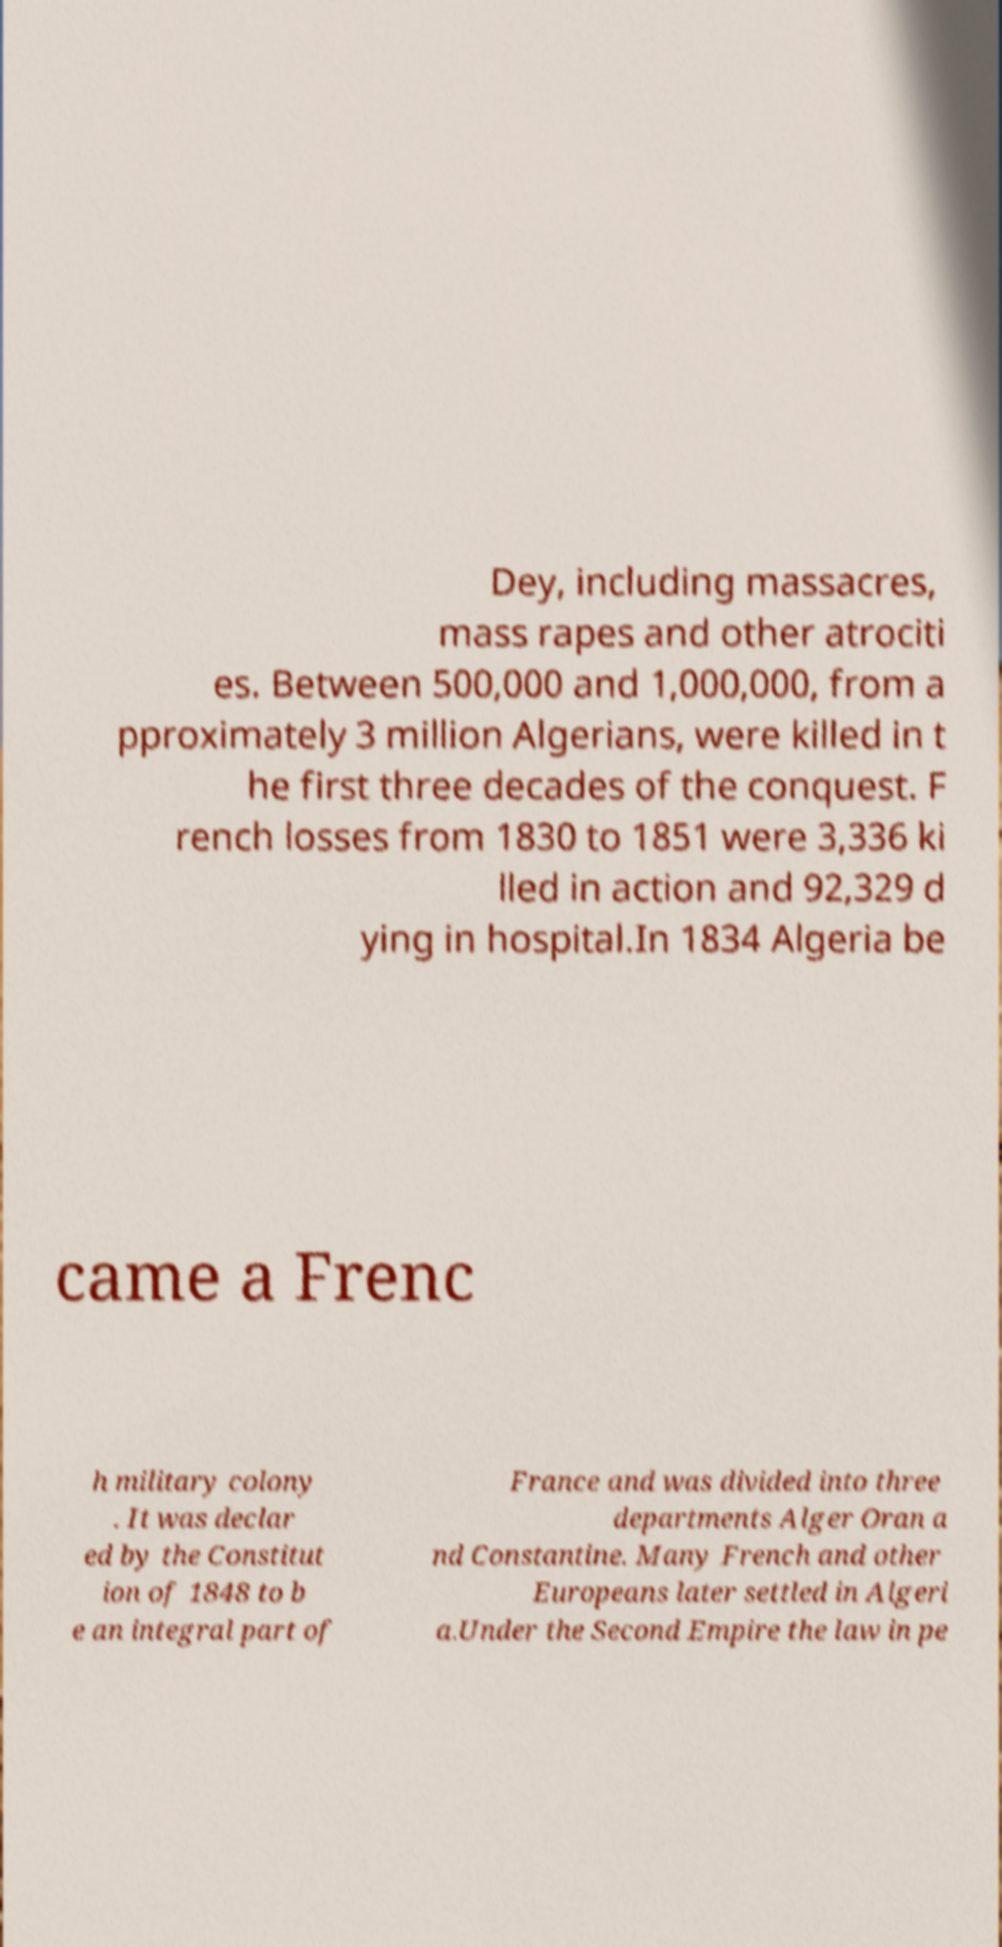Could you extract and type out the text from this image? Dey, including massacres, mass rapes and other atrociti es. Between 500,000 and 1,000,000, from a pproximately 3 million Algerians, were killed in t he first three decades of the conquest. F rench losses from 1830 to 1851 were 3,336 ki lled in action and 92,329 d ying in hospital.In 1834 Algeria be came a Frenc h military colony . It was declar ed by the Constitut ion of 1848 to b e an integral part of France and was divided into three departments Alger Oran a nd Constantine. Many French and other Europeans later settled in Algeri a.Under the Second Empire the law in pe 